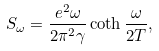<formula> <loc_0><loc_0><loc_500><loc_500>S _ { \omega } = \frac { e ^ { 2 } \omega } { 2 \pi ^ { 2 } \gamma } \coth \frac { \omega } { 2 T } ,</formula> 